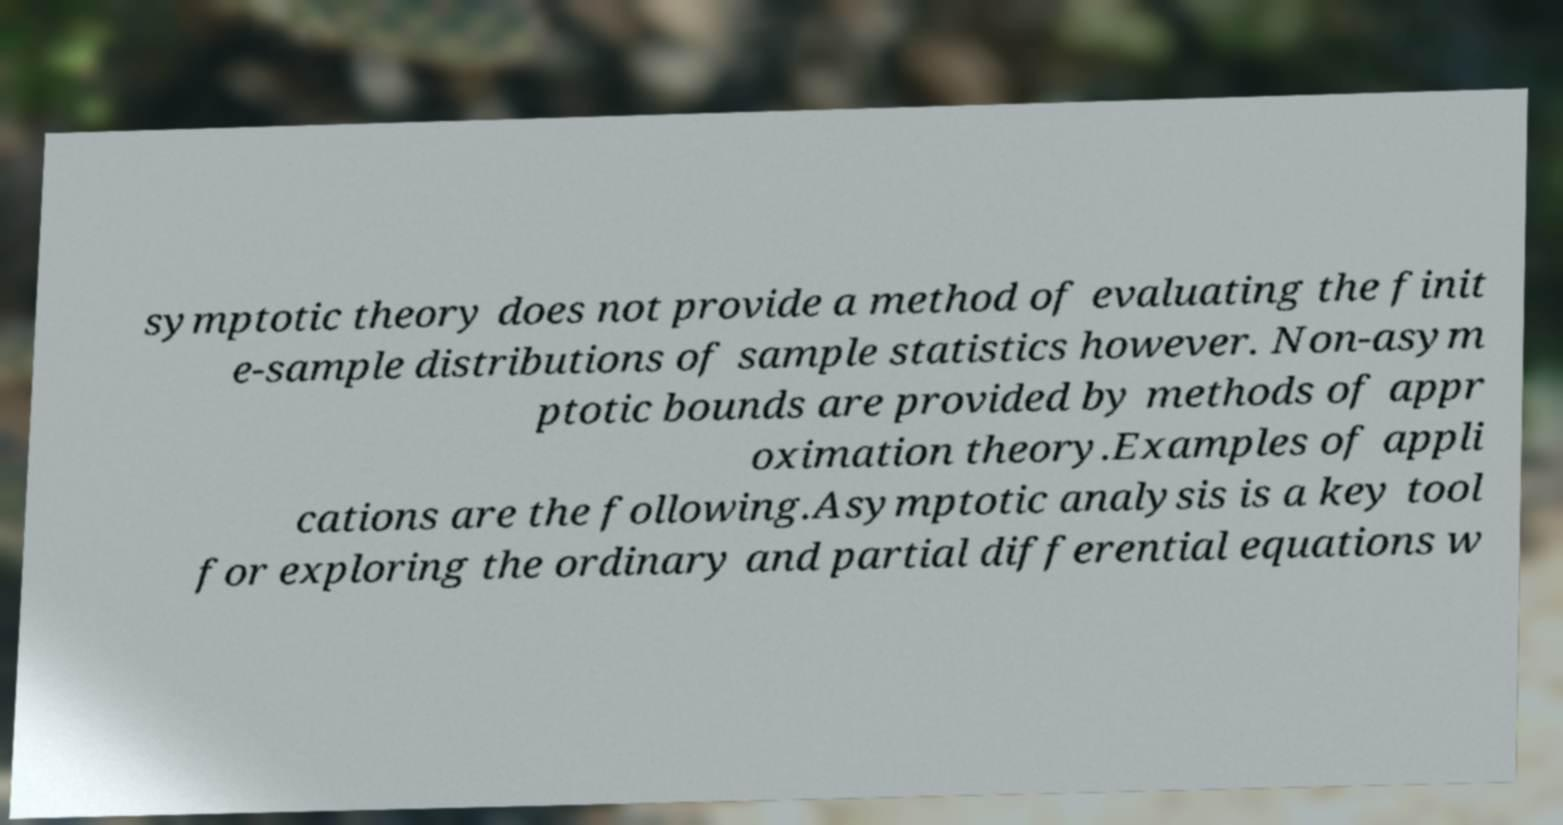What messages or text are displayed in this image? I need them in a readable, typed format. symptotic theory does not provide a method of evaluating the finit e-sample distributions of sample statistics however. Non-asym ptotic bounds are provided by methods of appr oximation theory.Examples of appli cations are the following.Asymptotic analysis is a key tool for exploring the ordinary and partial differential equations w 